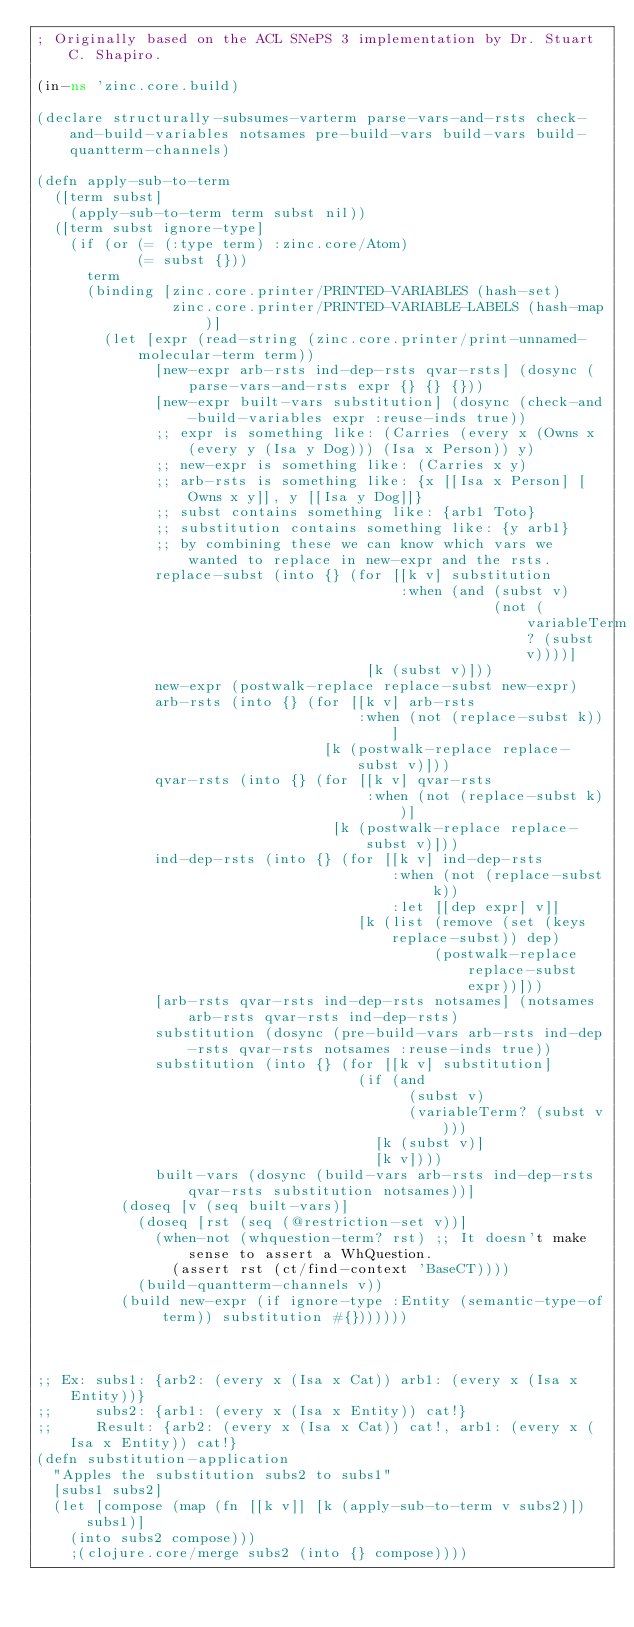<code> <loc_0><loc_0><loc_500><loc_500><_Clojure_>; Originally based on the ACL SNePS 3 implementation by Dr. Stuart C. Shapiro.

(in-ns 'zinc.core.build)

(declare structurally-subsumes-varterm parse-vars-and-rsts check-and-build-variables notsames pre-build-vars build-vars build-quantterm-channels)

(defn apply-sub-to-term
  ([term subst]
    (apply-sub-to-term term subst nil))
  ([term subst ignore-type]
    (if (or (= (:type term) :zinc.core/Atom)
            (= subst {}))
      term
      (binding [zinc.core.printer/PRINTED-VARIABLES (hash-set)
                zinc.core.printer/PRINTED-VARIABLE-LABELS (hash-map)]
        (let [expr (read-string (zinc.core.printer/print-unnamed-molecular-term term))
              [new-expr arb-rsts ind-dep-rsts qvar-rsts] (dosync (parse-vars-and-rsts expr {} {} {}))
              [new-expr built-vars substitution] (dosync (check-and-build-variables expr :reuse-inds true))
              ;; expr is something like: (Carries (every x (Owns x (every y (Isa y Dog))) (Isa x Person)) y)
              ;; new-expr is something like: (Carries x y)
              ;; arb-rsts is something like: {x [[Isa x Person] [Owns x y]], y [[Isa y Dog]]}
              ;; subst contains something like: {arb1 Toto}
              ;; substitution contains something like: {y arb1}
              ;; by combining these we can know which vars we wanted to replace in new-expr and the rsts.
              replace-subst (into {} (for [[k v] substitution
                                           :when (and (subst v)
                                                      (not (variableTerm? (subst v))))]
                                       [k (subst v)]))
              new-expr (postwalk-replace replace-subst new-expr)
              arb-rsts (into {} (for [[k v] arb-rsts
                                      :when (not (replace-subst k))]
                                  [k (postwalk-replace replace-subst v)]))
              qvar-rsts (into {} (for [[k v] qvar-rsts
                                       :when (not (replace-subst k))]
                                   [k (postwalk-replace replace-subst v)]))
              ind-dep-rsts (into {} (for [[k v] ind-dep-rsts
                                          :when (not (replace-subst k))
                                          :let [[dep expr] v]]
                                      [k (list (remove (set (keys replace-subst)) dep)
                                               (postwalk-replace replace-subst expr))]))
              [arb-rsts qvar-rsts ind-dep-rsts notsames] (notsames arb-rsts qvar-rsts ind-dep-rsts)
              substitution (dosync (pre-build-vars arb-rsts ind-dep-rsts qvar-rsts notsames :reuse-inds true))
              substitution (into {} (for [[k v] substitution]
                                      (if (and 
                                            (subst v)
                                            (variableTerm? (subst v)))
                                        [k (subst v)]
                                        [k v])))
              built-vars (dosync (build-vars arb-rsts ind-dep-rsts qvar-rsts substitution notsames))]
          (doseq [v (seq built-vars)]
            (doseq [rst (seq (@restriction-set v))]
              (when-not (whquestion-term? rst) ;; It doesn't make sense to assert a WhQuestion.
                (assert rst (ct/find-context 'BaseCT))))
            (build-quantterm-channels v))
          (build new-expr (if ignore-type :Entity (semantic-type-of term)) substitution #{}))))))



;; Ex: subs1: {arb2: (every x (Isa x Cat)) arb1: (every x (Isa x Entity))}
;;     subs2: {arb1: (every x (Isa x Entity)) cat!}
;;     Result: {arb2: (every x (Isa x Cat)) cat!, arb1: (every x (Isa x Entity)) cat!}
(defn substitution-application
  "Apples the substitution subs2 to subs1"
  [subs1 subs2] 
  (let [compose (map (fn [[k v]] [k (apply-sub-to-term v subs2)]) subs1)]
    (into subs2 compose)))
    ;(clojure.core/merge subs2 (into {} compose))))
</code> 